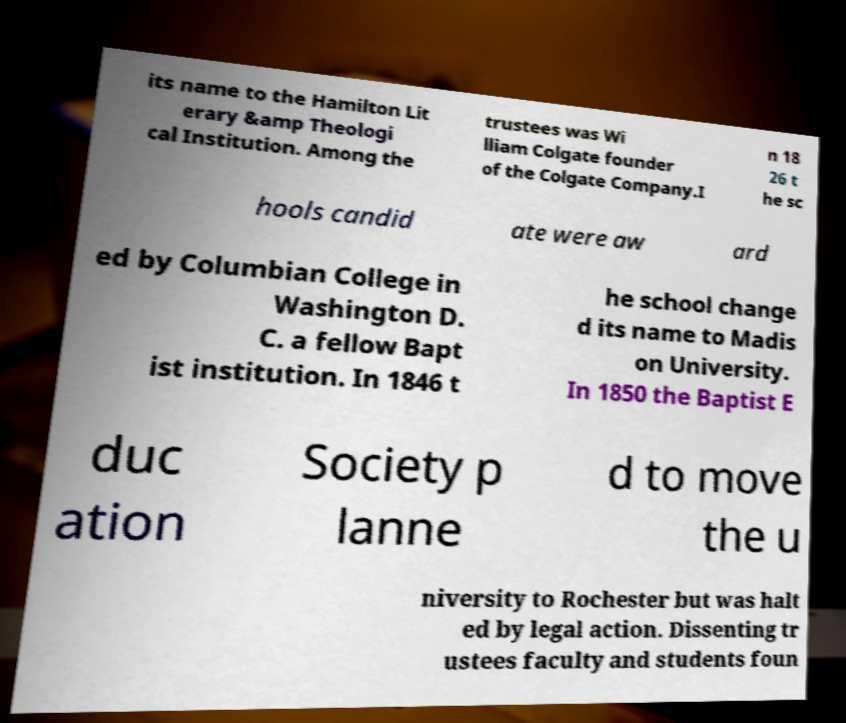Please read and relay the text visible in this image. What does it say? its name to the Hamilton Lit erary &amp Theologi cal Institution. Among the trustees was Wi lliam Colgate founder of the Colgate Company.I n 18 26 t he sc hools candid ate were aw ard ed by Columbian College in Washington D. C. a fellow Bapt ist institution. In 1846 t he school change d its name to Madis on University. In 1850 the Baptist E duc ation Society p lanne d to move the u niversity to Rochester but was halt ed by legal action. Dissenting tr ustees faculty and students foun 